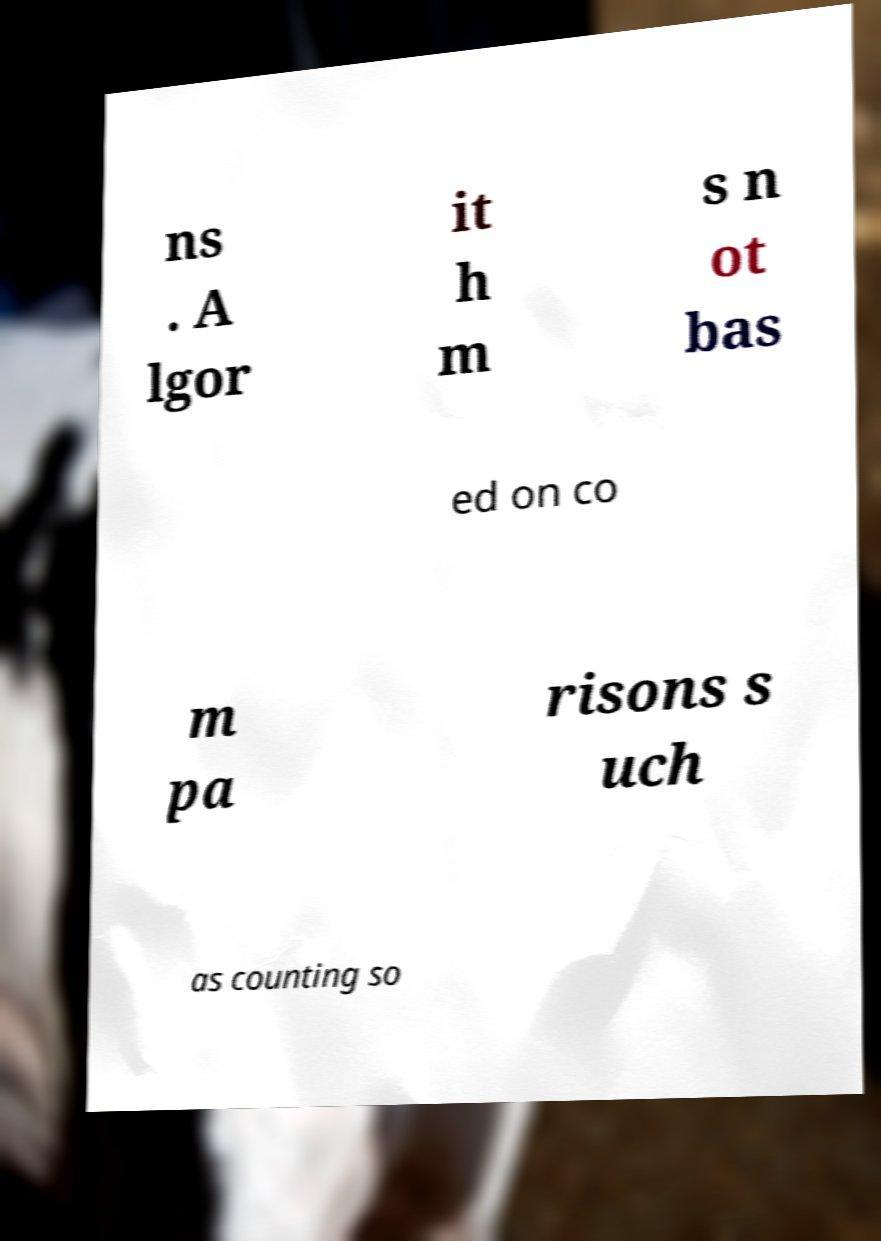Could you extract and type out the text from this image? ns . A lgor it h m s n ot bas ed on co m pa risons s uch as counting so 